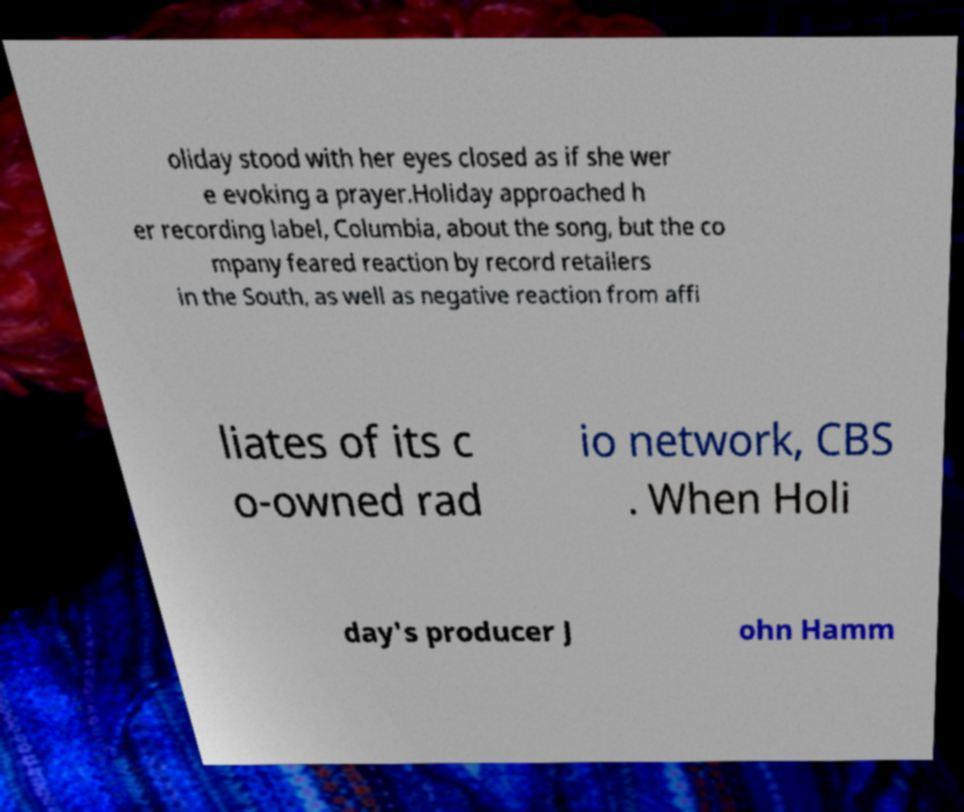Can you accurately transcribe the text from the provided image for me? oliday stood with her eyes closed as if she wer e evoking a prayer.Holiday approached h er recording label, Columbia, about the song, but the co mpany feared reaction by record retailers in the South, as well as negative reaction from affi liates of its c o-owned rad io network, CBS . When Holi day's producer J ohn Hamm 